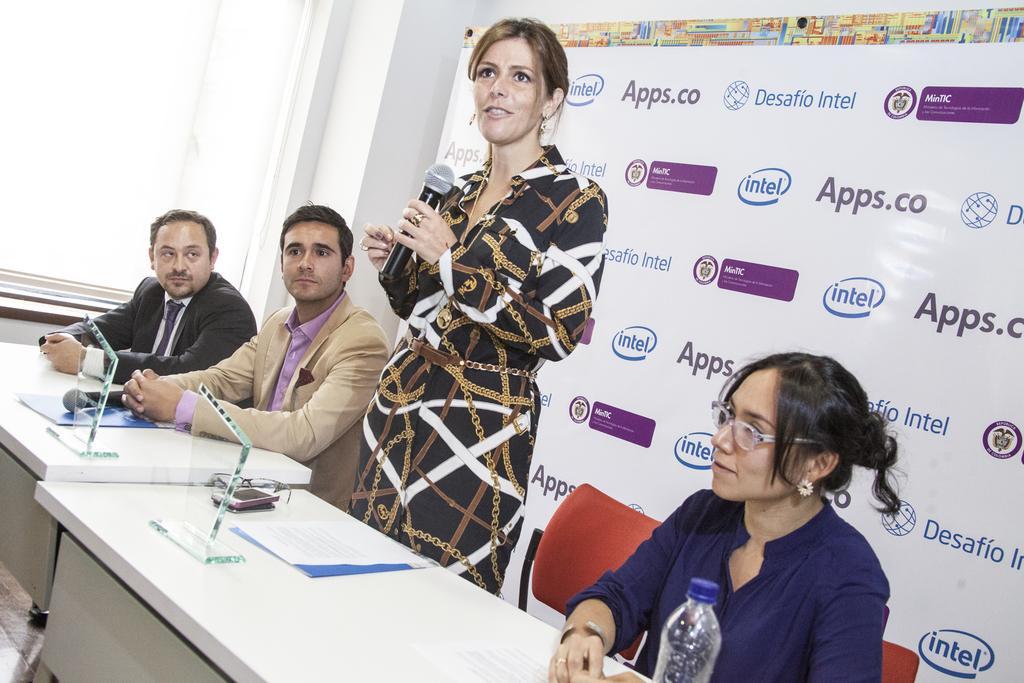Can you describe this image briefly? In this picture we can observe four members. Two of them are men and the remaining two are women. One of the woman is standing and holding a mic in her hand. In front of them there is a table on which we can observe some papers and a water bottle. In the background there is a poster. On the left side there is a window. 